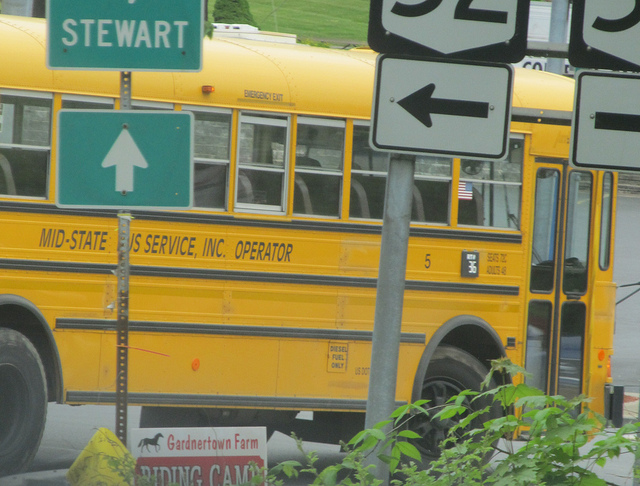Extract all visible text content from this image. MID- STEWART OPERATOR SERVICE. STATE o 35 5 CAM RIDING Farm Gardnertown INC. US 